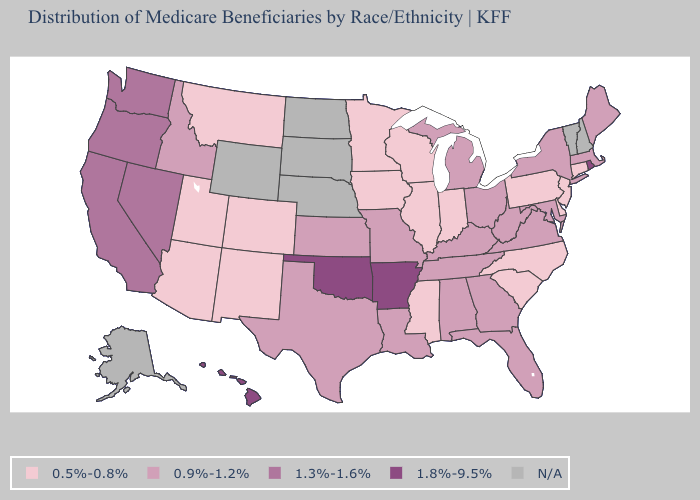What is the lowest value in the USA?
Give a very brief answer. 0.5%-0.8%. Which states have the lowest value in the USA?
Answer briefly. Arizona, Colorado, Connecticut, Delaware, Illinois, Indiana, Iowa, Minnesota, Mississippi, Montana, New Jersey, New Mexico, North Carolina, Pennsylvania, South Carolina, Utah, Wisconsin. How many symbols are there in the legend?
Concise answer only. 5. Name the states that have a value in the range 1.8%-9.5%?
Write a very short answer. Arkansas, Hawaii, Oklahoma, Rhode Island. What is the value of Montana?
Short answer required. 0.5%-0.8%. What is the lowest value in the USA?
Keep it brief. 0.5%-0.8%. What is the lowest value in the USA?
Be succinct. 0.5%-0.8%. Name the states that have a value in the range N/A?
Write a very short answer. Alaska, Nebraska, New Hampshire, North Dakota, South Dakota, Vermont, Wyoming. Is the legend a continuous bar?
Be succinct. No. Name the states that have a value in the range 0.9%-1.2%?
Short answer required. Alabama, Florida, Georgia, Idaho, Kansas, Kentucky, Louisiana, Maine, Maryland, Massachusetts, Michigan, Missouri, New York, Ohio, Tennessee, Texas, Virginia, West Virginia. Name the states that have a value in the range 0.5%-0.8%?
Write a very short answer. Arizona, Colorado, Connecticut, Delaware, Illinois, Indiana, Iowa, Minnesota, Mississippi, Montana, New Jersey, New Mexico, North Carolina, Pennsylvania, South Carolina, Utah, Wisconsin. 